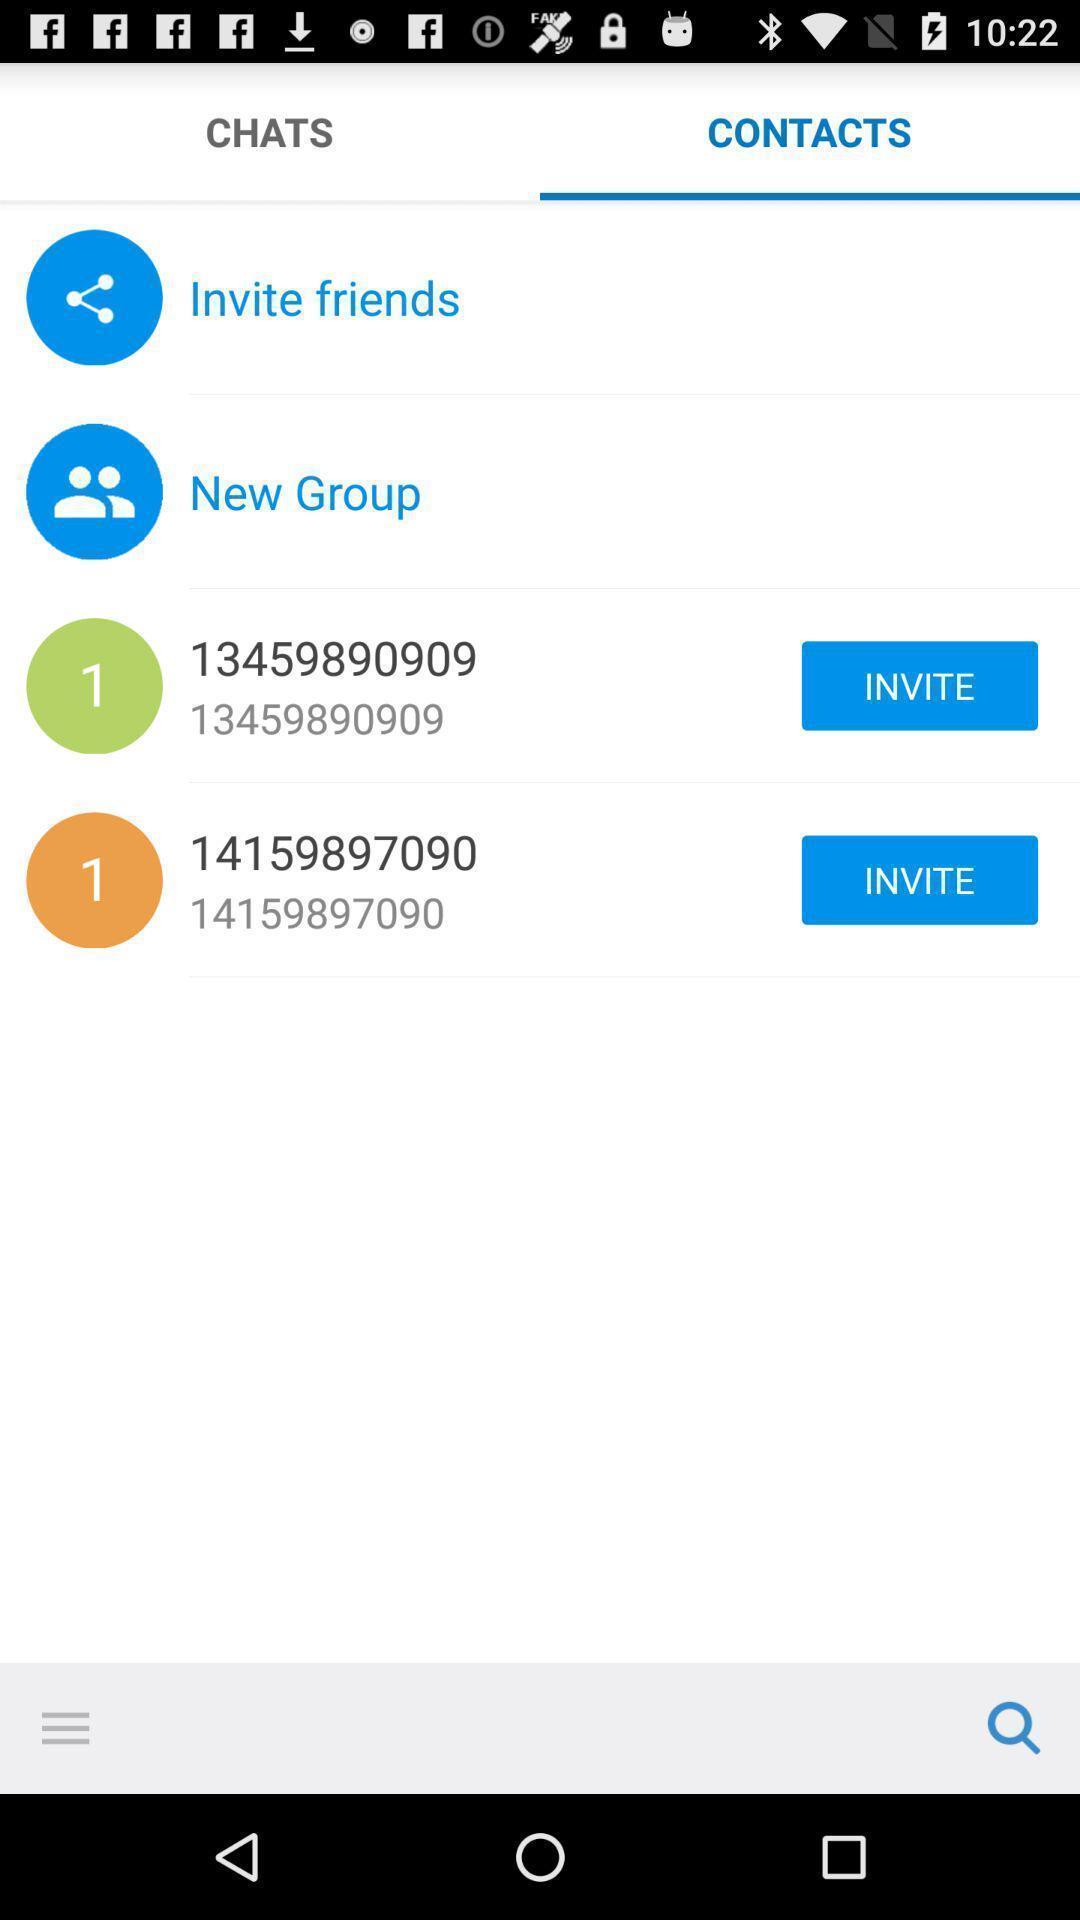Give me a summary of this screen capture. Page displaying the list of contacts. 